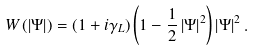Convert formula to latex. <formula><loc_0><loc_0><loc_500><loc_500>W \left ( \left | \Psi \right | \right ) = \left ( 1 + i \gamma _ { L } \right ) \left ( 1 - \frac { 1 } { 2 } \left | \Psi \right | ^ { 2 } \right ) \left | \Psi \right | ^ { 2 } .</formula> 